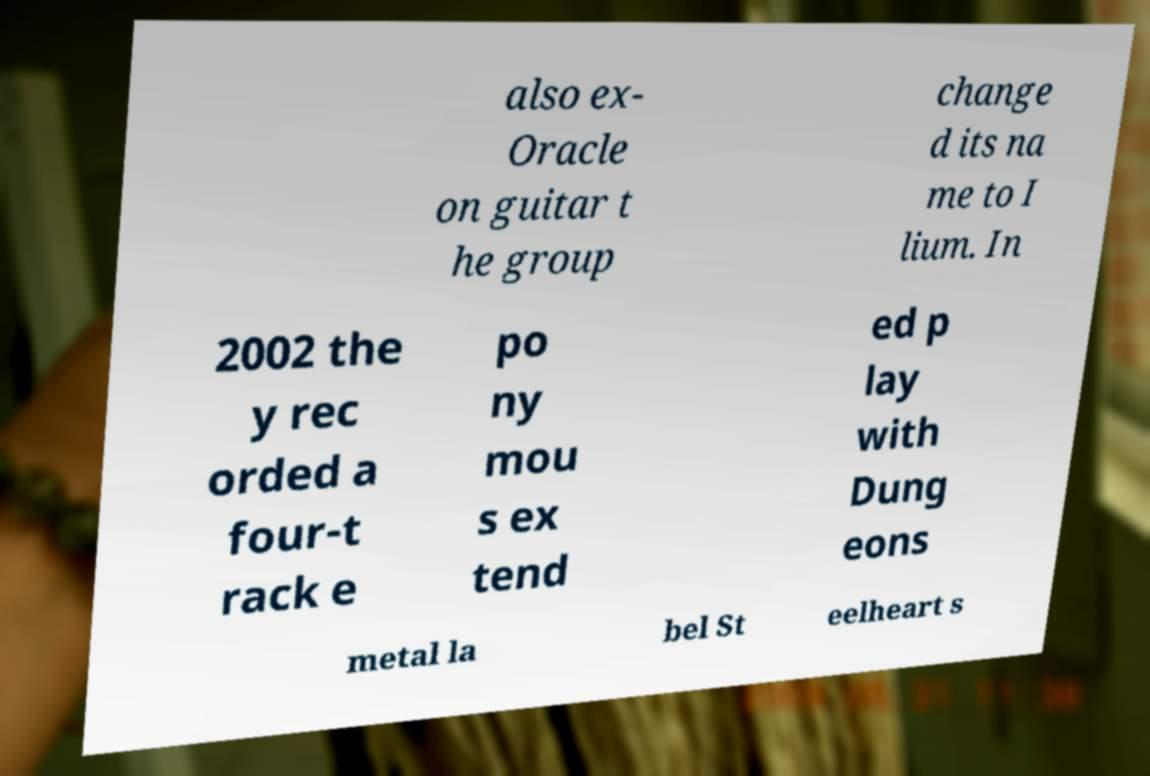I need the written content from this picture converted into text. Can you do that? also ex- Oracle on guitar t he group change d its na me to I lium. In 2002 the y rec orded a four-t rack e po ny mou s ex tend ed p lay with Dung eons metal la bel St eelheart s 